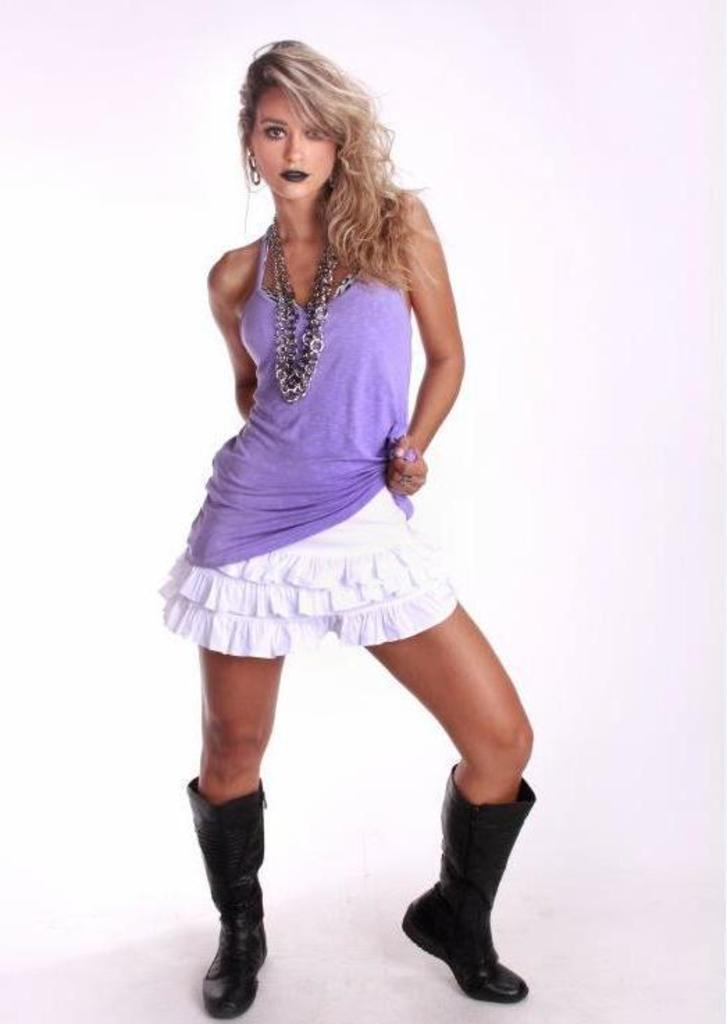What is the main subject of the image? There is a woman standing in the image. What can be seen in the background of the image? The background of the image is white. How many cakes are being carried by the woman in the image? There are no cakes visible in the image; the woman is not carrying anything. What is the woman's belief about the walk she is taking in the image? There is no indication of a walk in the image, and therefore no information about the woman's beliefs regarding it. 